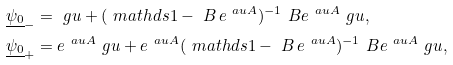<formula> <loc_0><loc_0><loc_500><loc_500>\underline { \psi _ { 0 } } _ { - } & = \ g u + ( \ m a t h d s { 1 } - \ B \, e ^ { \ a u A } ) ^ { - 1 } \ B e ^ { \ a u A } \ g u , \\ \underline { \psi _ { 0 } } _ { + } & = e ^ { \ a u A } \ g u + e ^ { \ a u A } ( \ m a t h d s { 1 } - \ B \, e ^ { \ a u A } ) ^ { - 1 } \ B e ^ { \ a u A } \ g u ,</formula> 